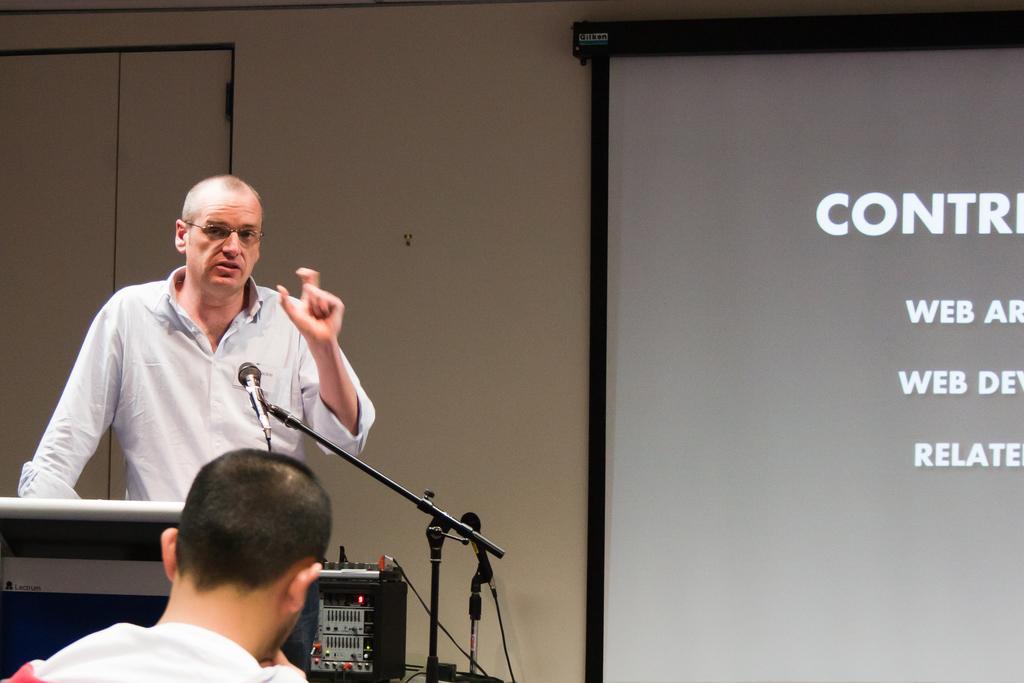Describe this image in one or two sentences. In this image there is a person standing on the dais and speaking in front of a mic, behind him there is a screen. 